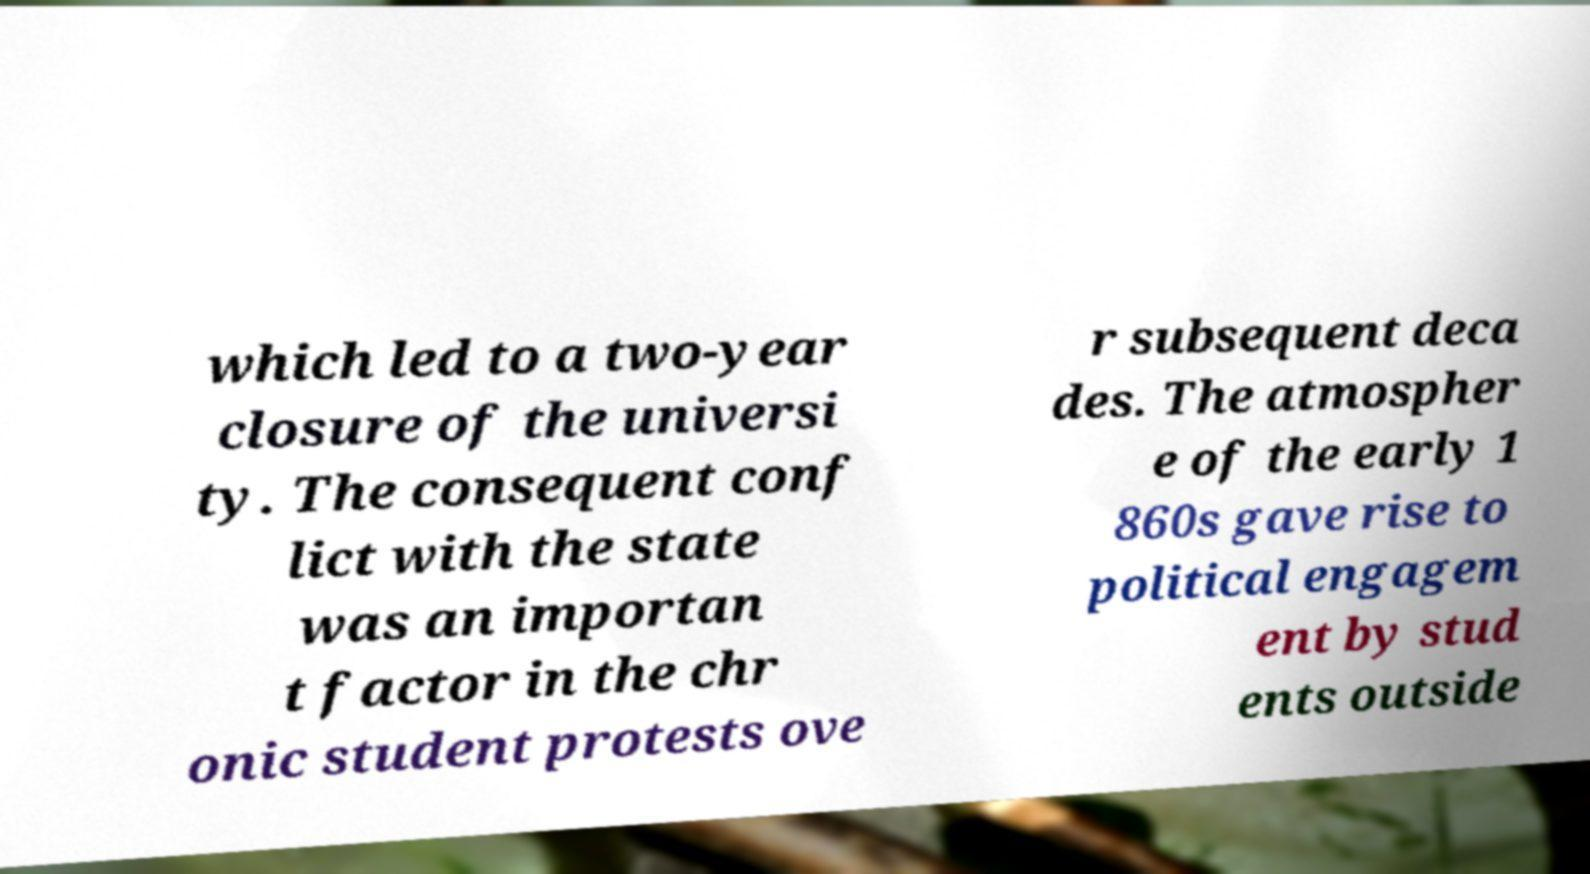What messages or text are displayed in this image? I need them in a readable, typed format. which led to a two-year closure of the universi ty. The consequent conf lict with the state was an importan t factor in the chr onic student protests ove r subsequent deca des. The atmospher e of the early 1 860s gave rise to political engagem ent by stud ents outside 